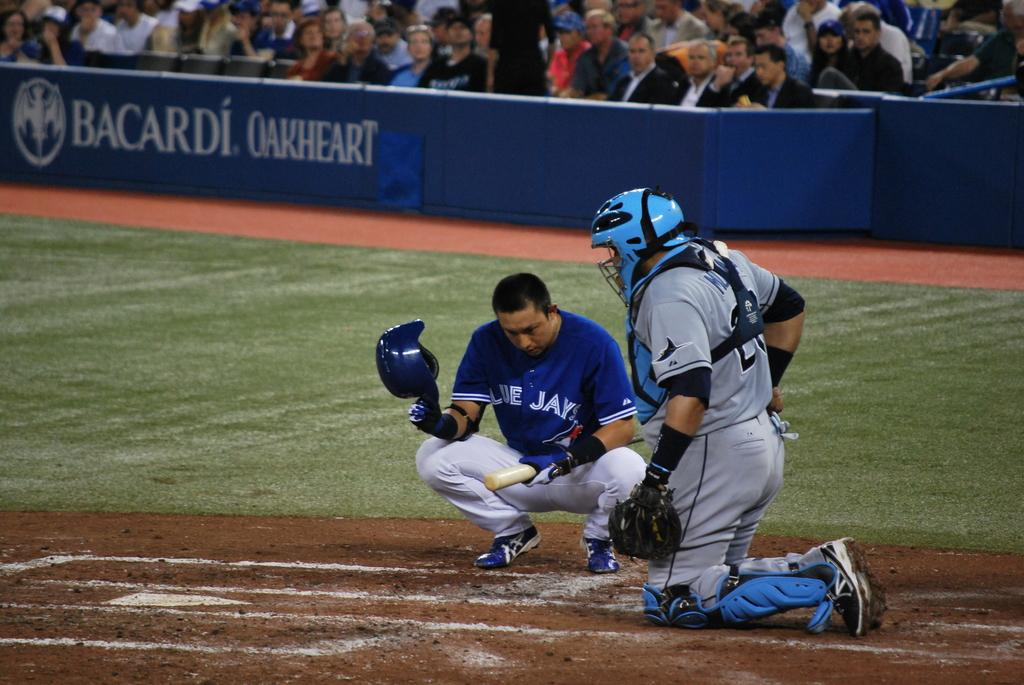<image>
Render a clear and concise summary of the photo. A man in a Blue Jay's jersey kneels near a base with an advertisement for BACARDI OAKHEART is in the background. 